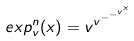<formula> <loc_0><loc_0><loc_500><loc_500>e x p _ { v } ^ { n } ( x ) = v ^ { v ^ { - ^ { - ^ { v ^ { x } } } } }</formula> 